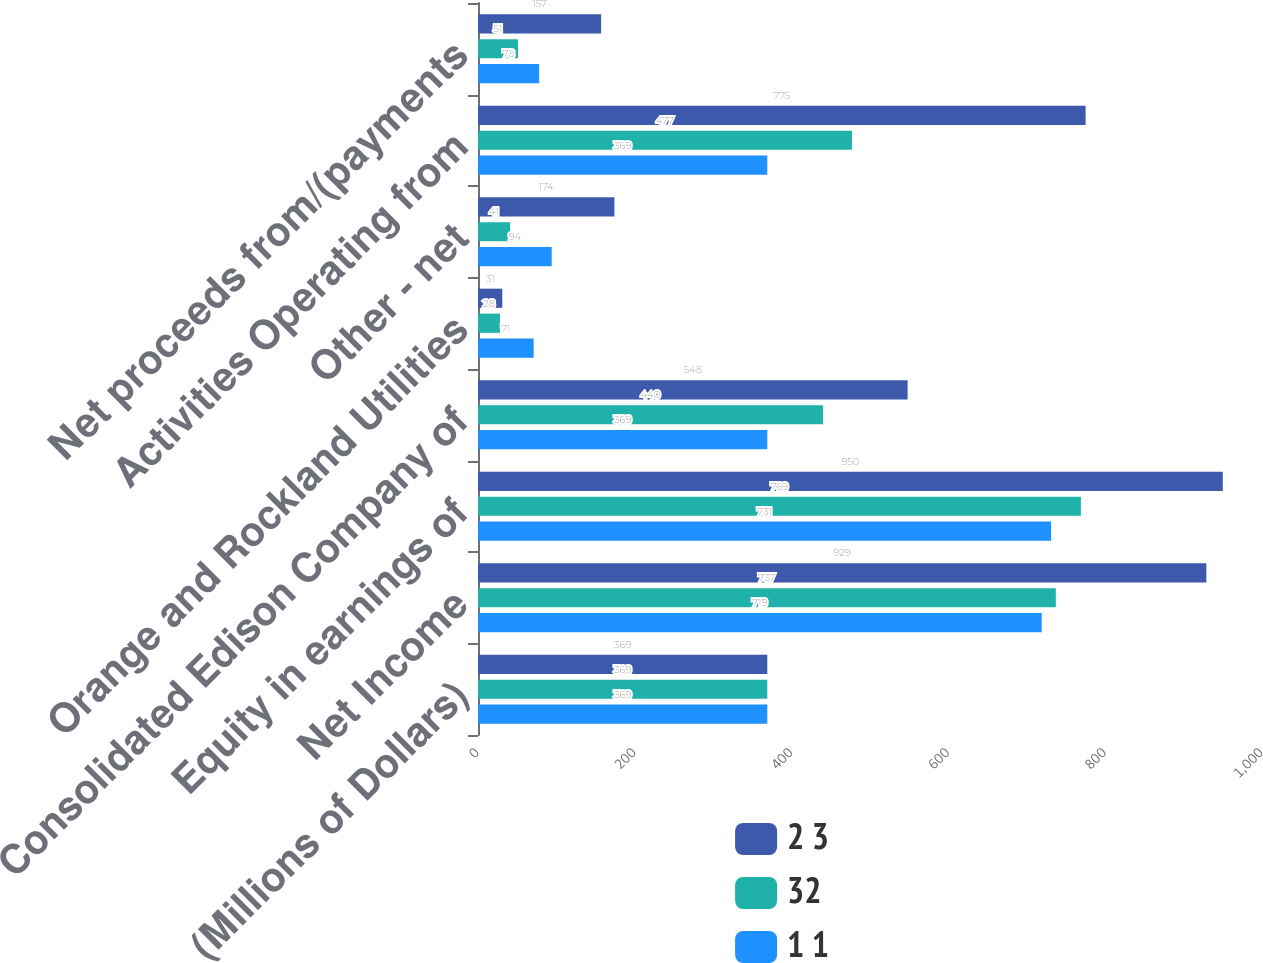<chart> <loc_0><loc_0><loc_500><loc_500><stacked_bar_chart><ecel><fcel>(Millions of Dollars)<fcel>Net Income<fcel>Equity in earnings of<fcel>Consolidated Edison Company of<fcel>Orange and Rockland Utilities<fcel>Other - net<fcel>Activities Operating from<fcel>Net proceeds from/(payments<nl><fcel>2 3<fcel>369<fcel>929<fcel>950<fcel>548<fcel>31<fcel>174<fcel>775<fcel>157<nl><fcel>32<fcel>369<fcel>737<fcel>769<fcel>440<fcel>28<fcel>41<fcel>477<fcel>51<nl><fcel>1 1<fcel>369<fcel>719<fcel>731<fcel>369<fcel>71<fcel>94<fcel>369<fcel>78<nl></chart> 